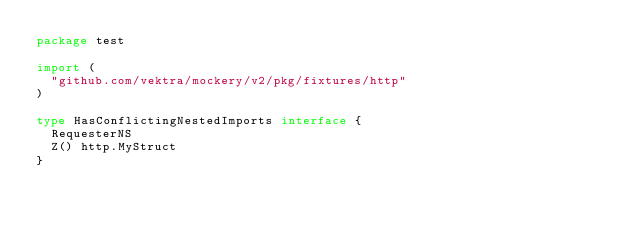<code> <loc_0><loc_0><loc_500><loc_500><_Go_>package test

import (
	"github.com/vektra/mockery/v2/pkg/fixtures/http"
)

type HasConflictingNestedImports interface {
	RequesterNS
	Z() http.MyStruct
}
</code> 